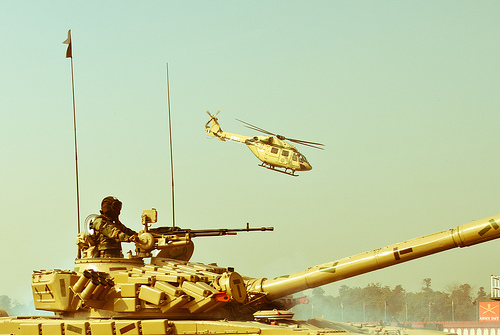<image>
Is the helicopter above the tank? Yes. The helicopter is positioned above the tank in the vertical space, higher up in the scene. 